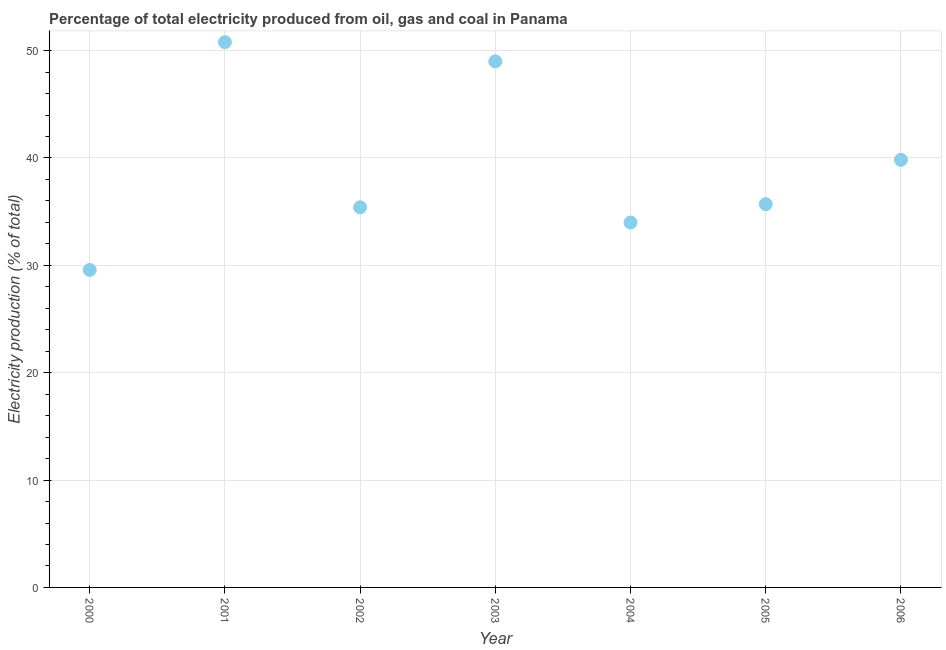What is the electricity production in 2001?
Keep it short and to the point. 50.78. Across all years, what is the maximum electricity production?
Make the answer very short. 50.78. Across all years, what is the minimum electricity production?
Ensure brevity in your answer.  29.57. What is the sum of the electricity production?
Offer a very short reply. 274.26. What is the difference between the electricity production in 2000 and 2003?
Your answer should be very brief. -19.43. What is the average electricity production per year?
Give a very brief answer. 39.18. What is the median electricity production?
Keep it short and to the point. 35.7. What is the ratio of the electricity production in 2003 to that in 2004?
Your answer should be compact. 1.44. Is the difference between the electricity production in 2000 and 2001 greater than the difference between any two years?
Offer a terse response. Yes. What is the difference between the highest and the second highest electricity production?
Provide a succinct answer. 1.78. What is the difference between the highest and the lowest electricity production?
Provide a succinct answer. 21.21. In how many years, is the electricity production greater than the average electricity production taken over all years?
Provide a short and direct response. 3. What is the title of the graph?
Your answer should be very brief. Percentage of total electricity produced from oil, gas and coal in Panama. What is the label or title of the Y-axis?
Offer a very short reply. Electricity production (% of total). What is the Electricity production (% of total) in 2000?
Offer a terse response. 29.57. What is the Electricity production (% of total) in 2001?
Ensure brevity in your answer.  50.78. What is the Electricity production (% of total) in 2002?
Your answer should be very brief. 35.41. What is the Electricity production (% of total) in 2003?
Your answer should be compact. 49. What is the Electricity production (% of total) in 2004?
Provide a succinct answer. 33.99. What is the Electricity production (% of total) in 2005?
Offer a very short reply. 35.7. What is the Electricity production (% of total) in 2006?
Keep it short and to the point. 39.82. What is the difference between the Electricity production (% of total) in 2000 and 2001?
Offer a terse response. -21.21. What is the difference between the Electricity production (% of total) in 2000 and 2002?
Make the answer very short. -5.84. What is the difference between the Electricity production (% of total) in 2000 and 2003?
Make the answer very short. -19.43. What is the difference between the Electricity production (% of total) in 2000 and 2004?
Your answer should be compact. -4.42. What is the difference between the Electricity production (% of total) in 2000 and 2005?
Ensure brevity in your answer.  -6.13. What is the difference between the Electricity production (% of total) in 2000 and 2006?
Your answer should be compact. -10.25. What is the difference between the Electricity production (% of total) in 2001 and 2002?
Make the answer very short. 15.38. What is the difference between the Electricity production (% of total) in 2001 and 2003?
Your answer should be very brief. 1.78. What is the difference between the Electricity production (% of total) in 2001 and 2004?
Ensure brevity in your answer.  16.79. What is the difference between the Electricity production (% of total) in 2001 and 2005?
Give a very brief answer. 15.08. What is the difference between the Electricity production (% of total) in 2001 and 2006?
Your response must be concise. 10.96. What is the difference between the Electricity production (% of total) in 2002 and 2003?
Ensure brevity in your answer.  -13.59. What is the difference between the Electricity production (% of total) in 2002 and 2004?
Your answer should be very brief. 1.42. What is the difference between the Electricity production (% of total) in 2002 and 2005?
Ensure brevity in your answer.  -0.29. What is the difference between the Electricity production (% of total) in 2002 and 2006?
Ensure brevity in your answer.  -4.42. What is the difference between the Electricity production (% of total) in 2003 and 2004?
Give a very brief answer. 15.01. What is the difference between the Electricity production (% of total) in 2003 and 2005?
Your response must be concise. 13.3. What is the difference between the Electricity production (% of total) in 2003 and 2006?
Make the answer very short. 9.17. What is the difference between the Electricity production (% of total) in 2004 and 2005?
Your response must be concise. -1.71. What is the difference between the Electricity production (% of total) in 2004 and 2006?
Offer a very short reply. -5.84. What is the difference between the Electricity production (% of total) in 2005 and 2006?
Provide a short and direct response. -4.13. What is the ratio of the Electricity production (% of total) in 2000 to that in 2001?
Make the answer very short. 0.58. What is the ratio of the Electricity production (% of total) in 2000 to that in 2002?
Your answer should be very brief. 0.83. What is the ratio of the Electricity production (% of total) in 2000 to that in 2003?
Provide a succinct answer. 0.6. What is the ratio of the Electricity production (% of total) in 2000 to that in 2004?
Make the answer very short. 0.87. What is the ratio of the Electricity production (% of total) in 2000 to that in 2005?
Your answer should be compact. 0.83. What is the ratio of the Electricity production (% of total) in 2000 to that in 2006?
Make the answer very short. 0.74. What is the ratio of the Electricity production (% of total) in 2001 to that in 2002?
Ensure brevity in your answer.  1.43. What is the ratio of the Electricity production (% of total) in 2001 to that in 2003?
Offer a terse response. 1.04. What is the ratio of the Electricity production (% of total) in 2001 to that in 2004?
Your response must be concise. 1.49. What is the ratio of the Electricity production (% of total) in 2001 to that in 2005?
Give a very brief answer. 1.42. What is the ratio of the Electricity production (% of total) in 2001 to that in 2006?
Keep it short and to the point. 1.27. What is the ratio of the Electricity production (% of total) in 2002 to that in 2003?
Ensure brevity in your answer.  0.72. What is the ratio of the Electricity production (% of total) in 2002 to that in 2004?
Make the answer very short. 1.04. What is the ratio of the Electricity production (% of total) in 2002 to that in 2006?
Provide a short and direct response. 0.89. What is the ratio of the Electricity production (% of total) in 2003 to that in 2004?
Make the answer very short. 1.44. What is the ratio of the Electricity production (% of total) in 2003 to that in 2005?
Keep it short and to the point. 1.37. What is the ratio of the Electricity production (% of total) in 2003 to that in 2006?
Your answer should be very brief. 1.23. What is the ratio of the Electricity production (% of total) in 2004 to that in 2005?
Your answer should be very brief. 0.95. What is the ratio of the Electricity production (% of total) in 2004 to that in 2006?
Make the answer very short. 0.85. What is the ratio of the Electricity production (% of total) in 2005 to that in 2006?
Ensure brevity in your answer.  0.9. 